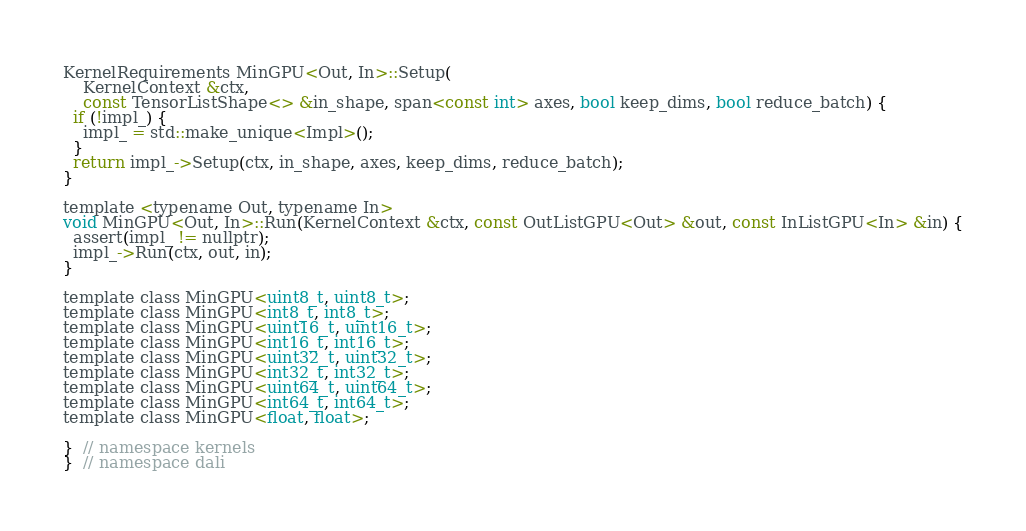Convert code to text. <code><loc_0><loc_0><loc_500><loc_500><_Cuda_>KernelRequirements MinGPU<Out, In>::Setup(
    KernelContext &ctx,
    const TensorListShape<> &in_shape, span<const int> axes, bool keep_dims, bool reduce_batch) {
  if (!impl_) {
    impl_ = std::make_unique<Impl>();
  }
  return impl_->Setup(ctx, in_shape, axes, keep_dims, reduce_batch);
}

template <typename Out, typename In>
void MinGPU<Out, In>::Run(KernelContext &ctx, const OutListGPU<Out> &out, const InListGPU<In> &in) {
  assert(impl_ != nullptr);
  impl_->Run(ctx, out, in);
}

template class MinGPU<uint8_t, uint8_t>;
template class MinGPU<int8_t, int8_t>;
template class MinGPU<uint16_t, uint16_t>;
template class MinGPU<int16_t, int16_t>;
template class MinGPU<uint32_t, uint32_t>;
template class MinGPU<int32_t, int32_t>;
template class MinGPU<uint64_t, uint64_t>;
template class MinGPU<int64_t, int64_t>;
template class MinGPU<float, float>;

}  // namespace kernels
}  // namespace dali
</code> 